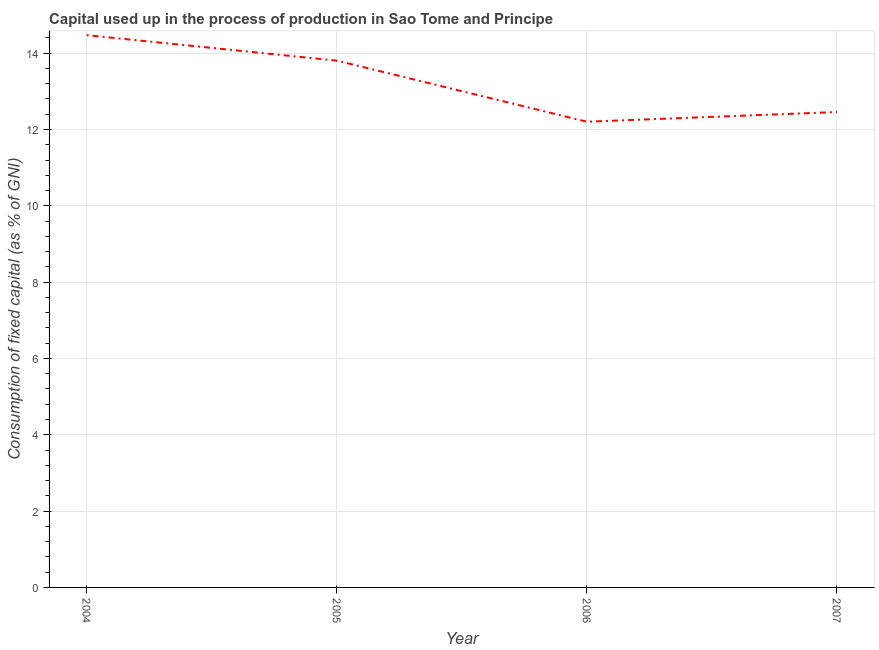What is the consumption of fixed capital in 2004?
Offer a very short reply. 14.47. Across all years, what is the maximum consumption of fixed capital?
Your answer should be compact. 14.47. Across all years, what is the minimum consumption of fixed capital?
Your answer should be very brief. 12.2. What is the sum of the consumption of fixed capital?
Make the answer very short. 52.94. What is the difference between the consumption of fixed capital in 2006 and 2007?
Offer a very short reply. -0.25. What is the average consumption of fixed capital per year?
Your answer should be very brief. 13.23. What is the median consumption of fixed capital?
Your answer should be very brief. 13.13. In how many years, is the consumption of fixed capital greater than 10 %?
Offer a terse response. 4. What is the ratio of the consumption of fixed capital in 2005 to that in 2006?
Keep it short and to the point. 1.13. Is the consumption of fixed capital in 2005 less than that in 2006?
Provide a succinct answer. No. What is the difference between the highest and the second highest consumption of fixed capital?
Ensure brevity in your answer.  0.67. What is the difference between the highest and the lowest consumption of fixed capital?
Your answer should be compact. 2.27. In how many years, is the consumption of fixed capital greater than the average consumption of fixed capital taken over all years?
Your answer should be compact. 2. Does the consumption of fixed capital monotonically increase over the years?
Ensure brevity in your answer.  No. How many years are there in the graph?
Your answer should be compact. 4. Are the values on the major ticks of Y-axis written in scientific E-notation?
Ensure brevity in your answer.  No. What is the title of the graph?
Your answer should be very brief. Capital used up in the process of production in Sao Tome and Principe. What is the label or title of the Y-axis?
Offer a very short reply. Consumption of fixed capital (as % of GNI). What is the Consumption of fixed capital (as % of GNI) in 2004?
Your answer should be very brief. 14.47. What is the Consumption of fixed capital (as % of GNI) of 2005?
Ensure brevity in your answer.  13.8. What is the Consumption of fixed capital (as % of GNI) of 2006?
Your answer should be compact. 12.2. What is the Consumption of fixed capital (as % of GNI) of 2007?
Offer a terse response. 12.46. What is the difference between the Consumption of fixed capital (as % of GNI) in 2004 and 2005?
Ensure brevity in your answer.  0.67. What is the difference between the Consumption of fixed capital (as % of GNI) in 2004 and 2006?
Offer a very short reply. 2.27. What is the difference between the Consumption of fixed capital (as % of GNI) in 2004 and 2007?
Offer a terse response. 2.01. What is the difference between the Consumption of fixed capital (as % of GNI) in 2005 and 2006?
Give a very brief answer. 1.6. What is the difference between the Consumption of fixed capital (as % of GNI) in 2005 and 2007?
Your response must be concise. 1.35. What is the difference between the Consumption of fixed capital (as % of GNI) in 2006 and 2007?
Give a very brief answer. -0.25. What is the ratio of the Consumption of fixed capital (as % of GNI) in 2004 to that in 2005?
Offer a very short reply. 1.05. What is the ratio of the Consumption of fixed capital (as % of GNI) in 2004 to that in 2006?
Make the answer very short. 1.19. What is the ratio of the Consumption of fixed capital (as % of GNI) in 2004 to that in 2007?
Ensure brevity in your answer.  1.16. What is the ratio of the Consumption of fixed capital (as % of GNI) in 2005 to that in 2006?
Provide a short and direct response. 1.13. What is the ratio of the Consumption of fixed capital (as % of GNI) in 2005 to that in 2007?
Offer a terse response. 1.11. What is the ratio of the Consumption of fixed capital (as % of GNI) in 2006 to that in 2007?
Keep it short and to the point. 0.98. 